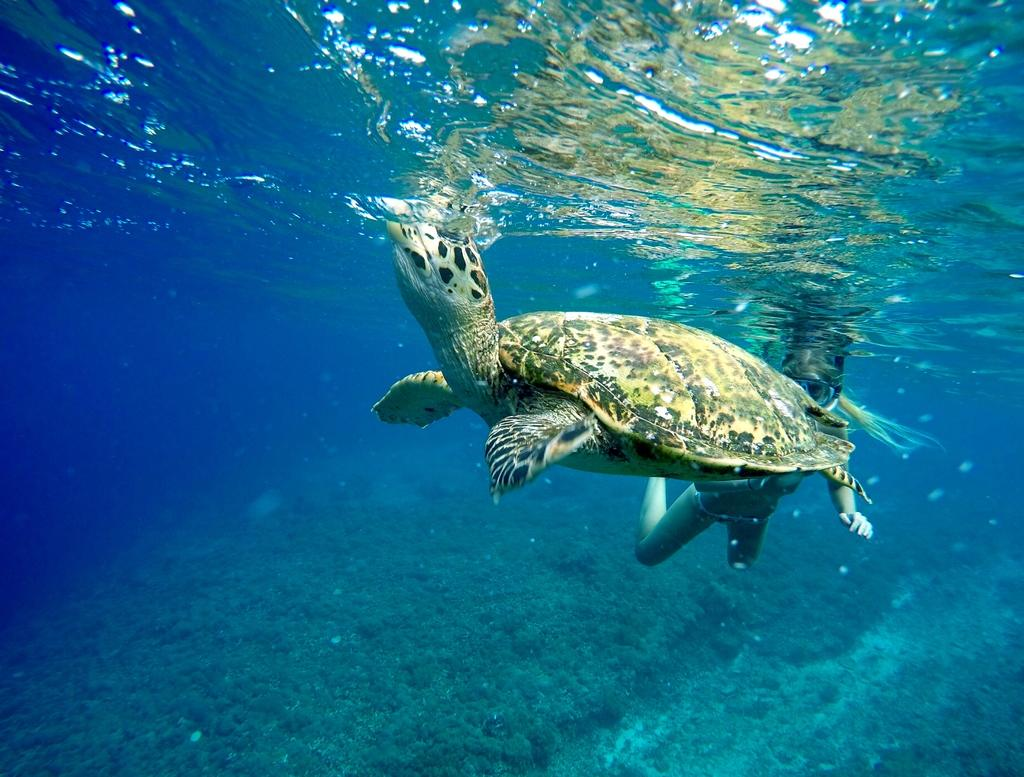What animal is present in the image? There is a turtle in the image. Who or what else is in the image? There is a person in the image. Where are the turtle and the person located? Both the turtle and the person are in the water. What type of garden can be seen in the image? There is no garden present in the image; it features a turtle and a person in the water. How does the stone interact with the turtle in the image? There is no stone present in the image, so it cannot interact with the turtle. 